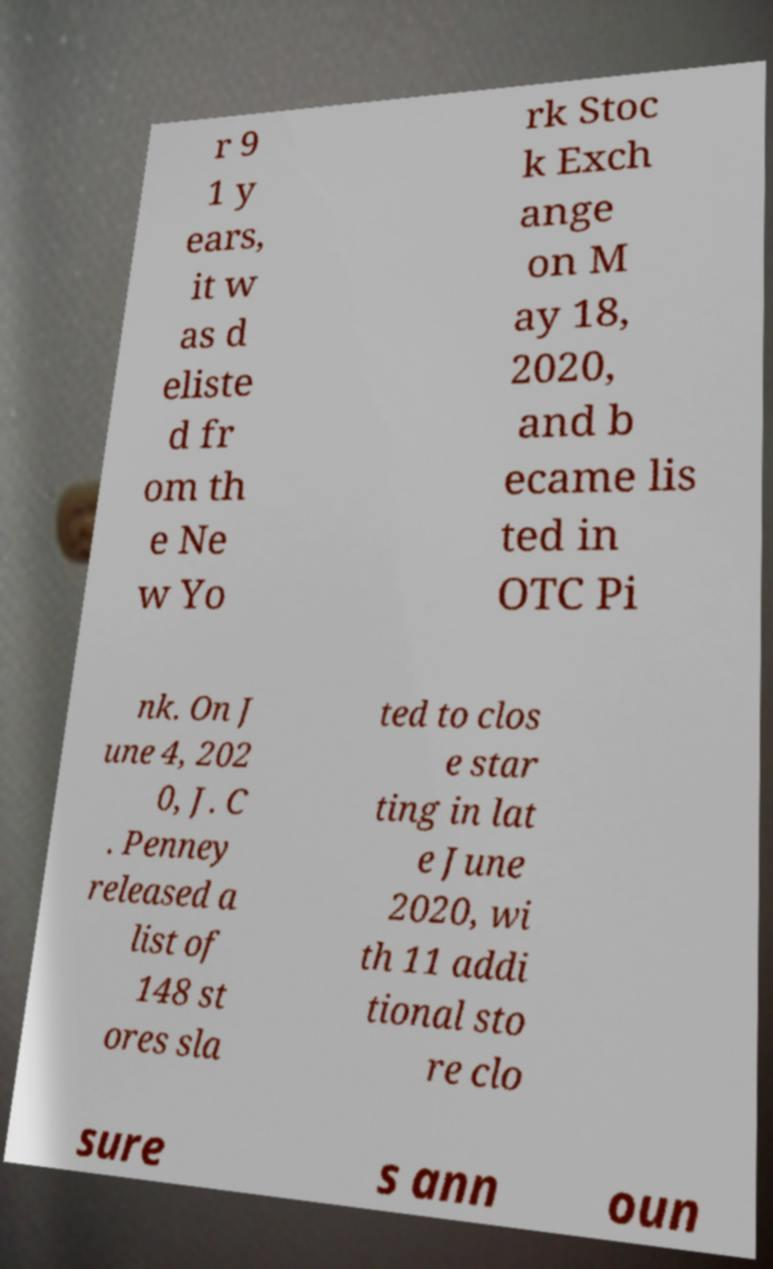For documentation purposes, I need the text within this image transcribed. Could you provide that? r 9 1 y ears, it w as d eliste d fr om th e Ne w Yo rk Stoc k Exch ange on M ay 18, 2020, and b ecame lis ted in OTC Pi nk. On J une 4, 202 0, J. C . Penney released a list of 148 st ores sla ted to clos e star ting in lat e June 2020, wi th 11 addi tional sto re clo sure s ann oun 